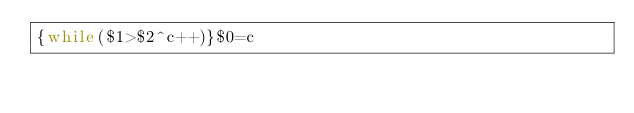<code> <loc_0><loc_0><loc_500><loc_500><_Awk_>{while($1>$2^c++)}$0=c</code> 